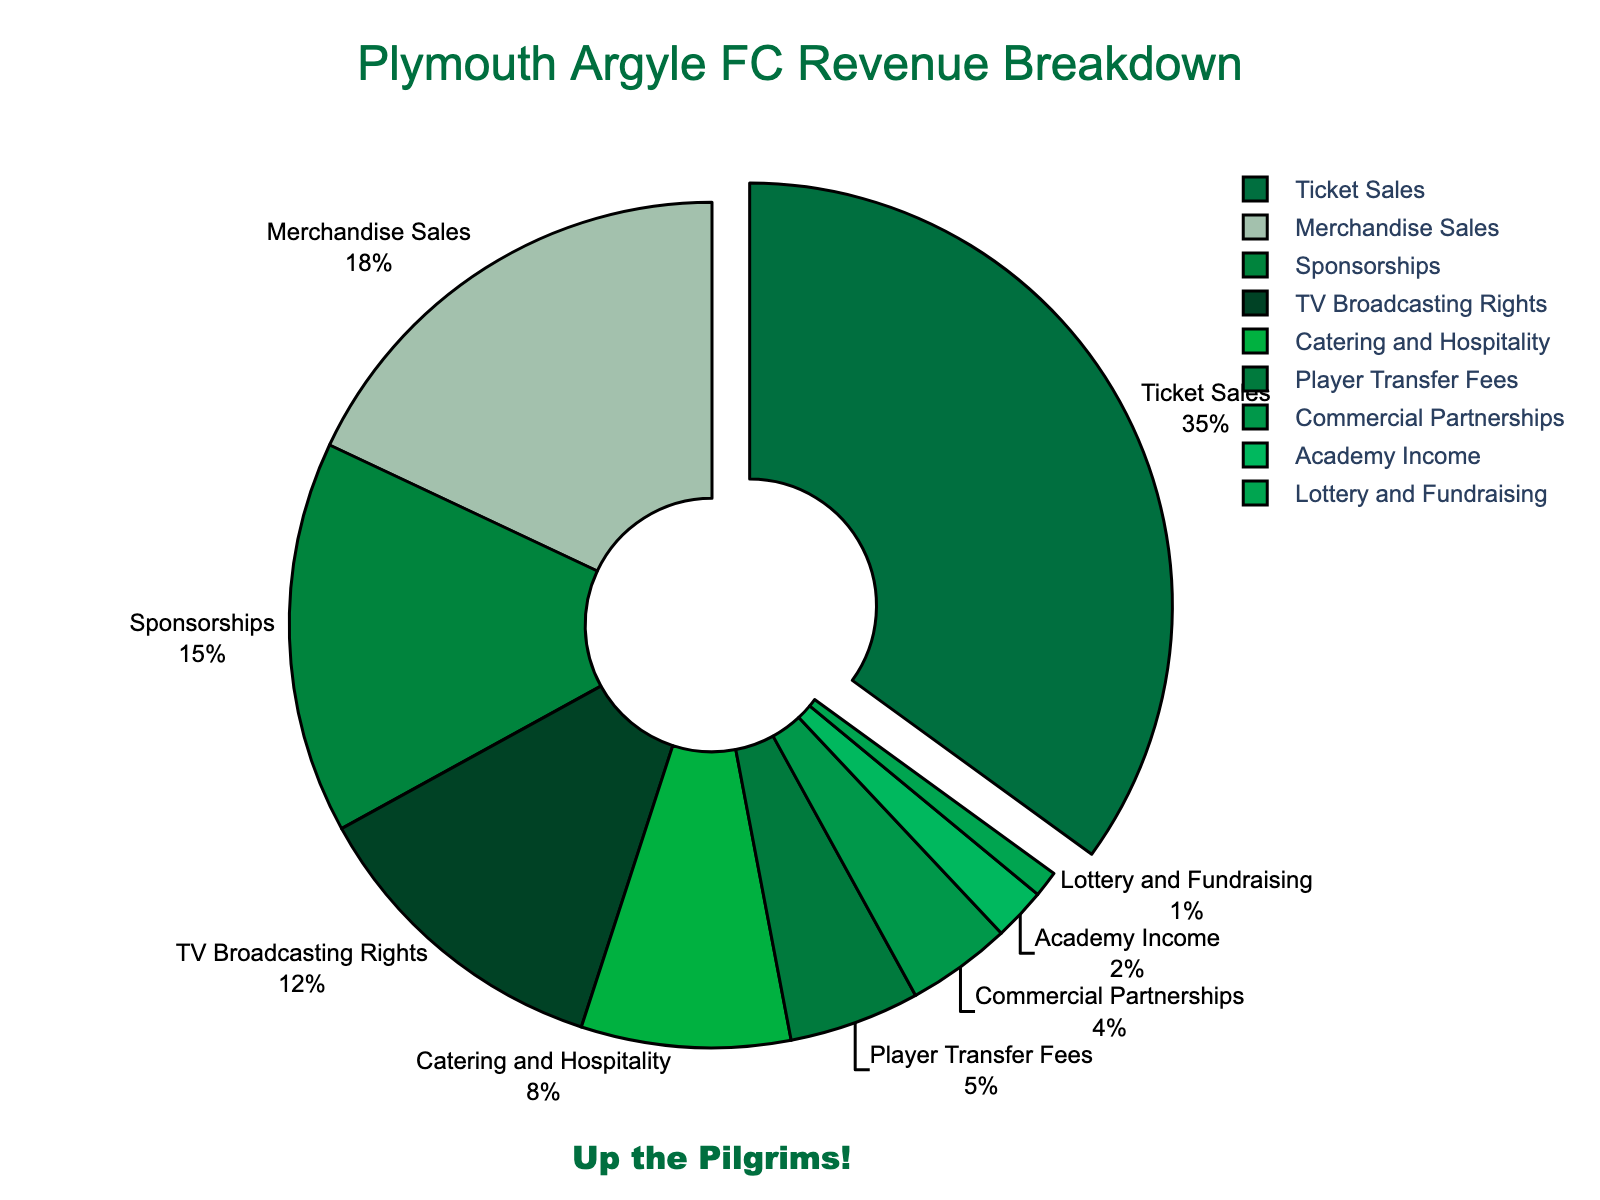What is the largest revenue source for Plymouth Argyle FC? The biggest segment of the pie chart is labeled "Ticket Sales" with 35%.
Answer: Ticket Sales How much more does Merchandise Sales contribute to the revenue compared to Player Transfer Fees? Merchandise Sales contributes 18% while Player Transfer Fees contribute 5%. The difference is calculated by subtracting 5% from 18%, which equals 13%.
Answer: 13% Which revenue source contributes the least to Plymouth Argyle FC’s revenue? The smallest segment of the pie chart is labeled "Lottery and Fundraising" with 1%.
Answer: Lottery and Fundraising What is the combined percentage contribution of TV Broadcasting Rights and Sponsorships? TV Broadcasting Rights contribute 12% and Sponsorships contribute 15%. Adding these together, 12% + 15% = 27%.
Answer: 27% Which revenue source is represented by the second largest segment? The second largest segment is labeled "Merchandise Sales" with 18%.
Answer: Merchandise Sales How much does Commercial Partnerships contribute relative to Catering and Hospitality? Commercial Partnerships contribute 4% while Catering and Hospitality contribute 8%. Dividing the smaller value (4%) by the larger value (8%) gives 0.5, indicating that Commercial Partnerships contribute half as much as Catering and Hospitality.
Answer: Half as much What is the difference in percentage points between the revenues from Ticket Sales and TV Broadcasting Rights? Ticket Sales contribute 35% and TV Broadcasting Rights contribute 12%. The difference is found by subtracting 12% from 35%, which equals 23 percentage points.
Answer: 23 percentage points If Academy Income and Player Transfer Fees were combined into one category, what percentage of total revenue would this new category represent? Player Transfer Fees contribute 5% and Academy Income contributes 2%. Adding these together, 5% + 2% = 7%.
Answer: 7% What is the total percentage of revenue generated from Ticket Sales, Merchandise Sales, and Sponsorships combined? Ticket Sales contribute 35%, Merchandise Sales contribute 18%, and Sponsorships contribute 15%. Adding these together, 35% + 18% + 15% = 68%.
Answer: 68% Which revenue category occupies the greenest shade in the pie chart? The pie chart uses shades of green, with the largest segment being Ticket Sales, which is identified as the greenest shade.
Answer: Ticket Sales 